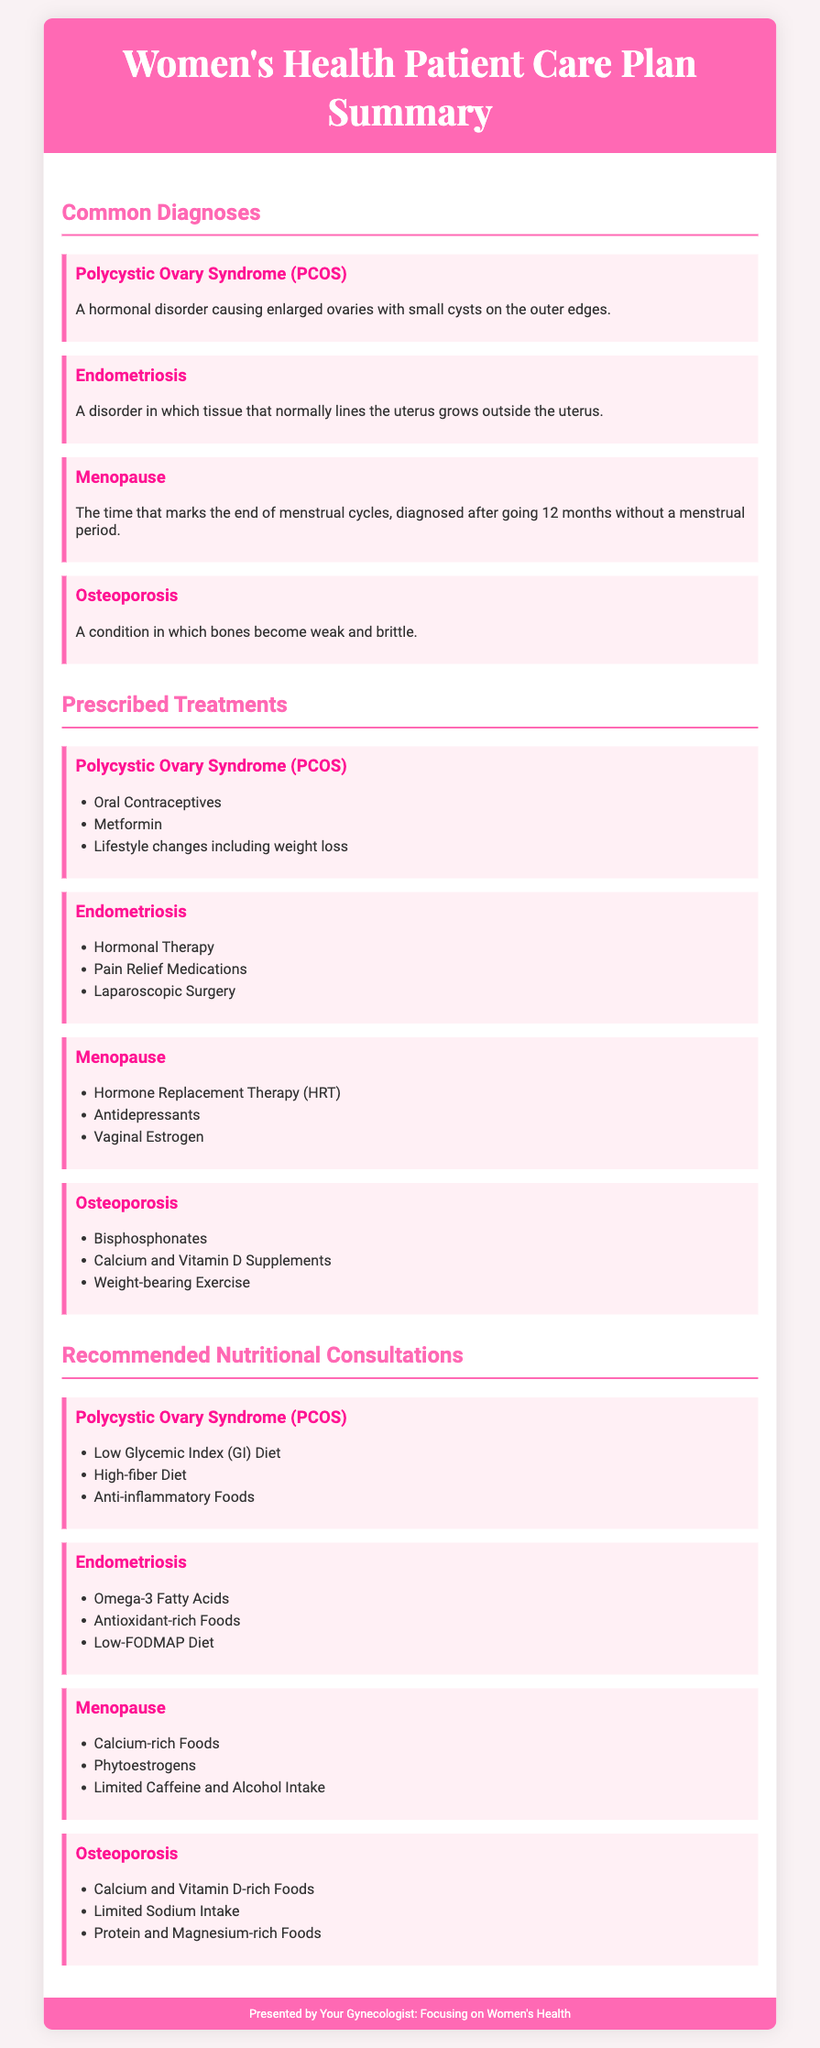What is a common diagnosis for hormonal disorders? The document lists Polycystic Ovary Syndrome (PCOS) as a common diagnosis for hormonal disorders in women.
Answer: Polycystic Ovary Syndrome (PCOS) What treatment is prescribed for Endometriosis? According to the document, one of the treatments prescribed for Endometriosis is Hormonal Therapy.
Answer: Hormonal Therapy What is a recommended diet for PCOS? The suggested nutritional consultation for PCOS includes following a Low Glycemic Index (GI) Diet.
Answer: Low Glycemic Index (GI) Diet How many treatments are listed for Osteoporosis? The document specifies three prescribed treatments for Osteoporosis.
Answer: Three What nutrient-rich foods are recommended for menopause? The document indicates that calcium-rich foods are recommended for menopause.
Answer: Calcium-rich Foods What type of surgery may be done for Endometriosis? The document states that Laparoscopic Surgery may be performed for Endometriosis.
Answer: Laparoscopic Surgery Which condition is diagnosed after going 12 months without a menstrual period? The document indicates that Menopause is diagnosed after going 12 months without a menstrual period.
Answer: Menopause What is the title of the document? The title provided at the top of the document is "Women's Health Patient Care Plan Summary."
Answer: Women's Health Patient Care Plan Summary 